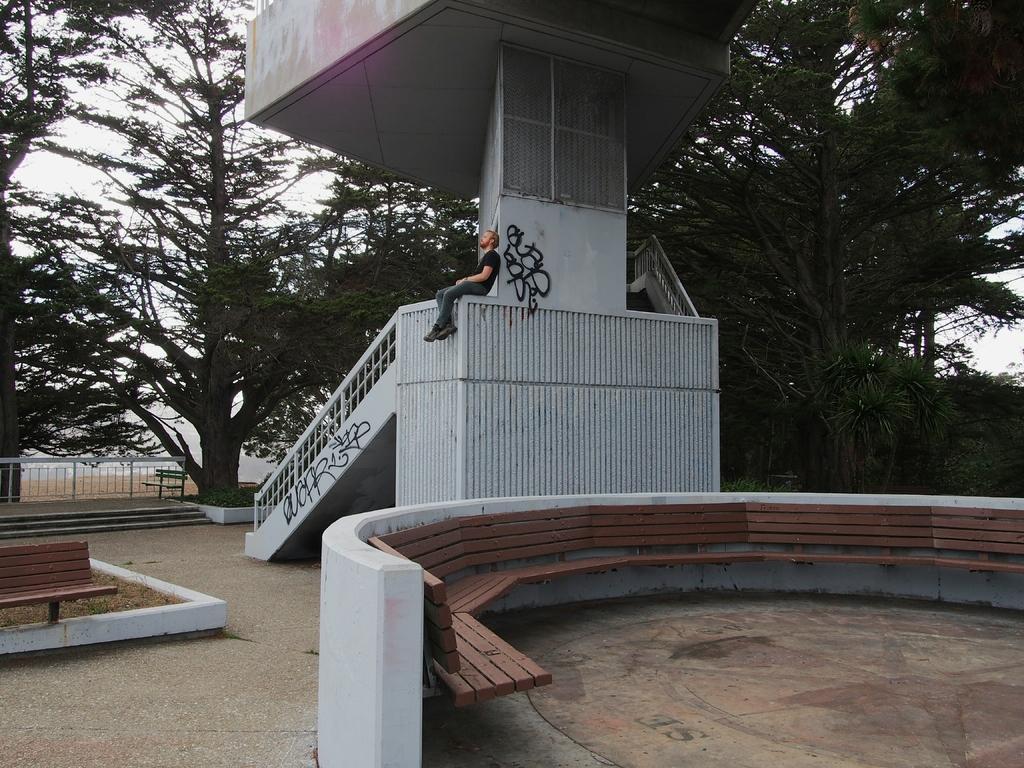In one or two sentences, can you explain what this image depicts? In this image we can see a person sitting on the wall and there is a pillar, stairs, railing, a bench on the ground and benches to the wall, trees and the sky in the background. 